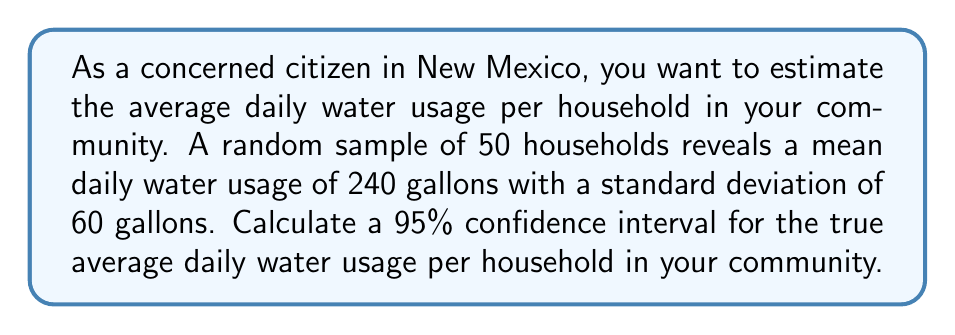Solve this math problem. Let's approach this step-by-step:

1) We're given:
   - Sample size: $n = 50$
   - Sample mean: $\bar{x} = 240$ gallons
   - Sample standard deviation: $s = 60$ gallons
   - Confidence level: 95%

2) For a 95% confidence interval, we use a $z$-score of 1.96.

3) The formula for the confidence interval is:

   $$\bar{x} \pm z \cdot \frac{s}{\sqrt{n}}$$

4) Let's calculate the standard error:
   
   $$\frac{s}{\sqrt{n}} = \frac{60}{\sqrt{50}} = \frac{60}{7.07} \approx 8.49$$

5) Now, let's calculate the margin of error:

   $$1.96 \cdot 8.49 \approx 16.64$$

6) Finally, we can calculate the confidence interval:

   Lower bound: $240 - 16.64 = 223.36$
   Upper bound: $240 + 16.64 = 256.64$

Therefore, we are 95% confident that the true average daily water usage per household in the community is between 223.36 and 256.64 gallons.
Answer: (223.36, 256.64) gallons 